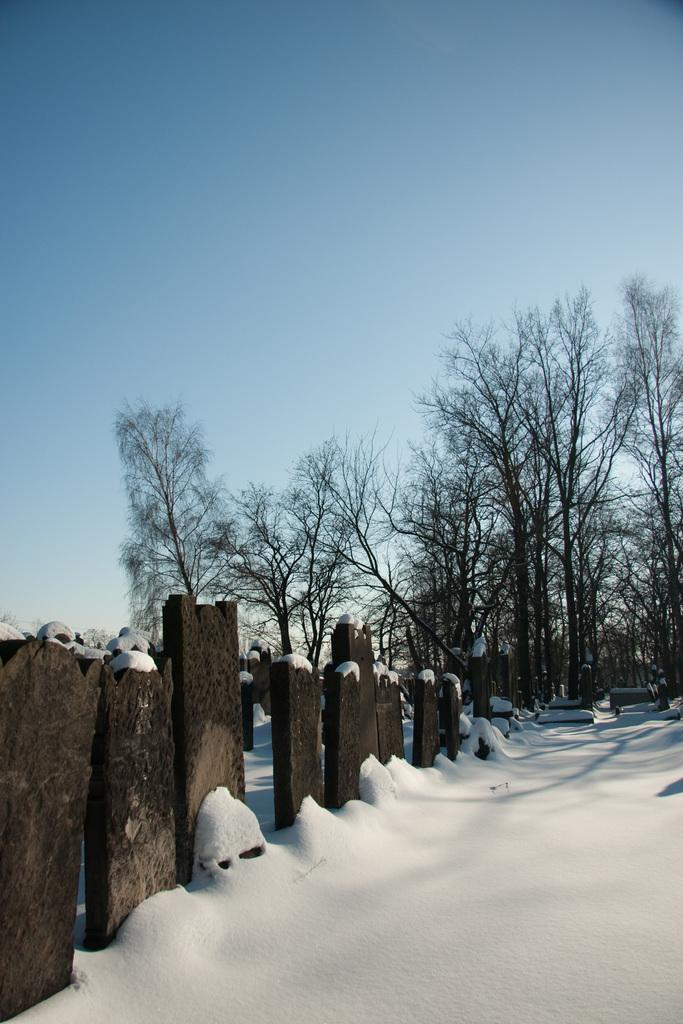What type of material is visible in the image? There are wooden logs in the image. What is the weather like in the image? There is snow visible in the image, indicating a cold or wintry environment. What can be seen in the background of the image? There are trees and the sky visible in the background of the image. What type of noise can be heard coming from the tent in the image? There is no tent present in the image, so it is not possible to determine what noise might be heard. 